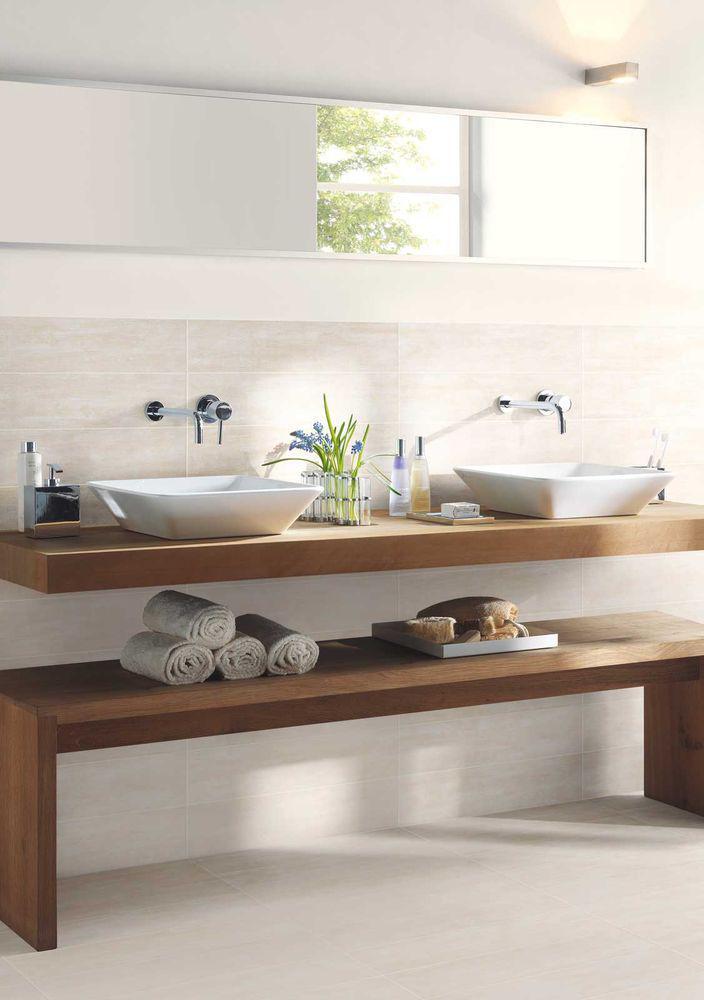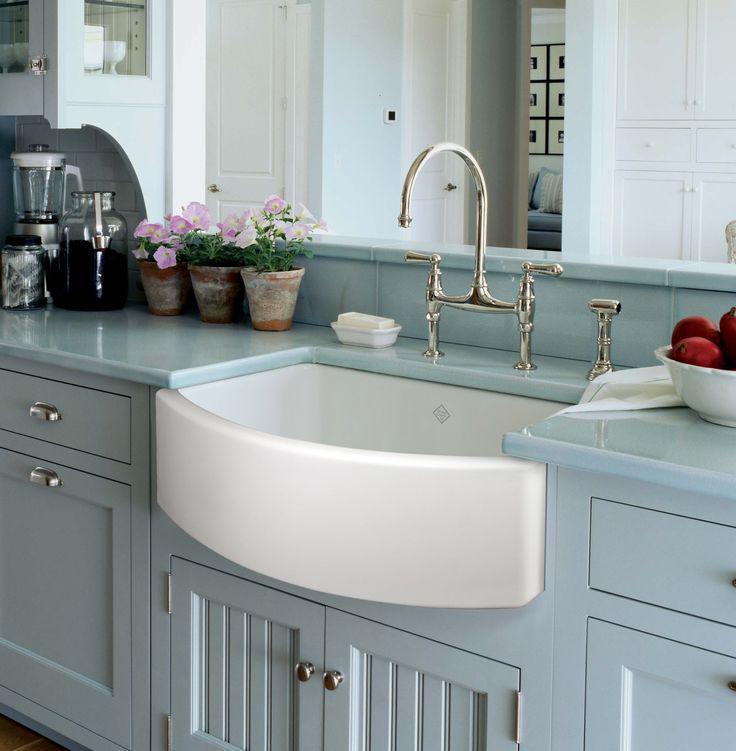The first image is the image on the left, the second image is the image on the right. Evaluate the accuracy of this statement regarding the images: "In one image, a bathroom vanity has two matching white sinks.". Is it true? Answer yes or no. Yes. The first image is the image on the left, the second image is the image on the right. Given the left and right images, does the statement "In 1 of the images, 1 sink has a window behind it." hold true? Answer yes or no. Yes. 